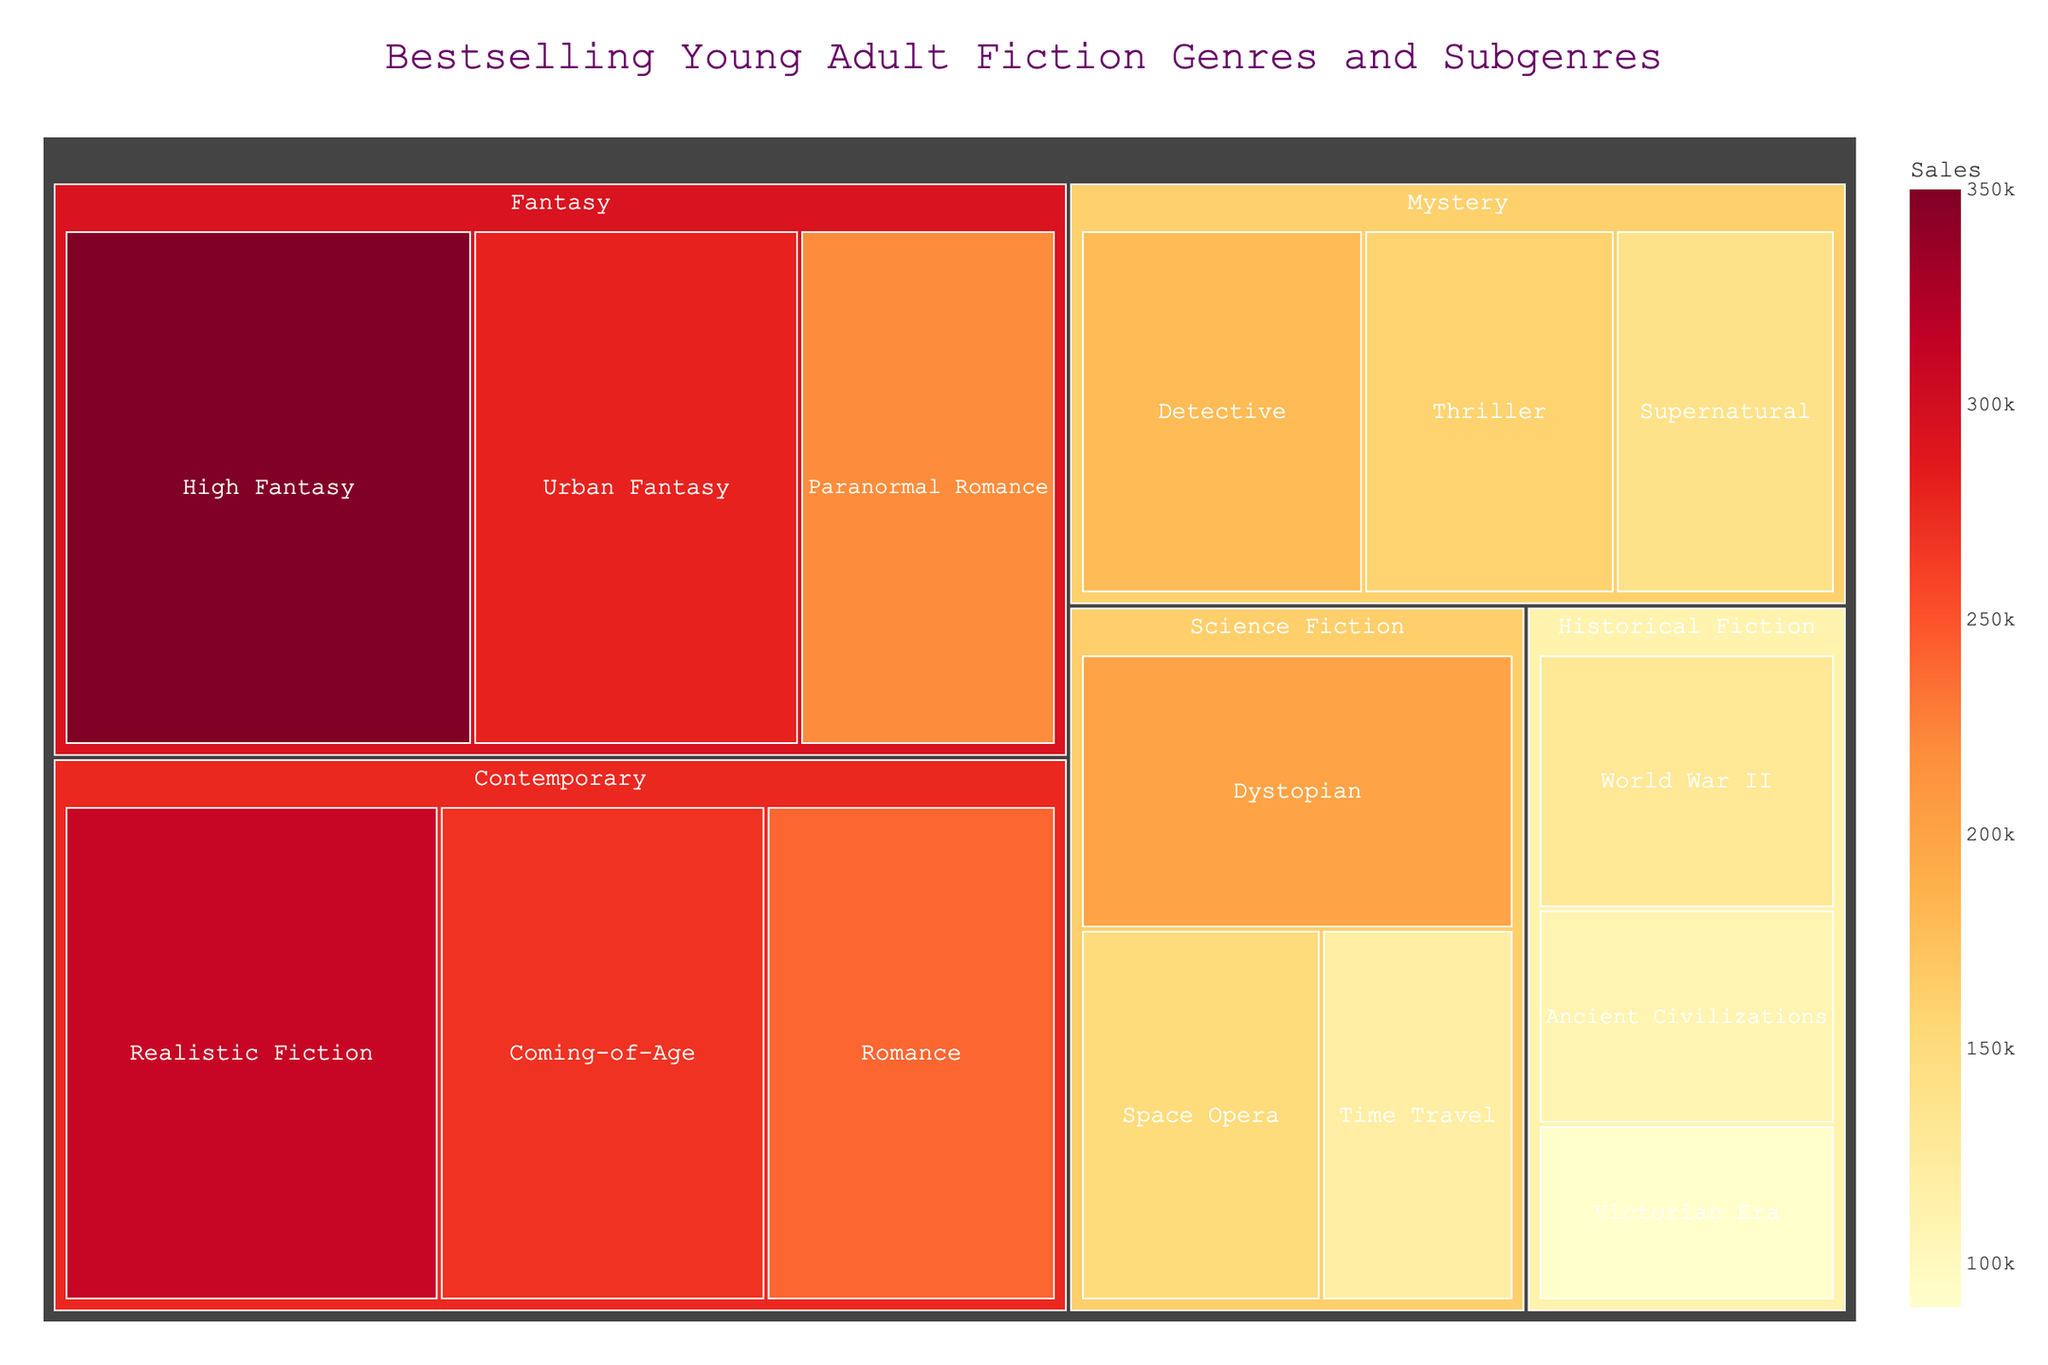What's the title of the figure? The title is usually found at the top of the treemap. It summarizes what the figure is about.
Answer: Bestselling Young Adult Fiction Genres and Subgenres Which subgenre has the highest sales in the Fantasy genre? Look at the Fantasy genre and identify the subgenre within it that has the highest numerical value for sales.
Answer: High Fantasy How much do the total sales for the Mystery genre amount to? Add the sales of all subgenres under the Mystery genre. Detective (180,000) + Thriller (160,000) + Supernatural (140,000) = 480,000
Answer: 480,000 Which subgenre in the Contemporary genre has the lowest sales? Find the subgenre within the Contemporary genre with the smallest sales number.
Answer: Romance Compare the sales of the top subgenre in Fantasy with the top subgenre in Historical Fiction. Which one is higher? Identify the top subgenre in both genres and compare their sales. High Fantasy in Fantasy (350,000) vs World War II in Historical Fiction (130,000).
Answer: High Fantasy What are the sales differences between the highest and lowest subgenre in Science Fiction? Subtract the sales of the lowest subgenre from the highest subgenre within Science Fiction. Space Opera (150,000) - Time Travel (120,000) = 30,000
Answer: 30,000 Which genre has the least total sales? Sum the sales of all subgenres within each genre and find the one with the smallest total. Historical Fiction: 130,000 + 110,000 + 90,000 = 330,000
Answer: Historical Fiction What is the color scale used to represent sales? The color scale indicates sales levels visually. Identify the described color scheme.
Answer: YlOrRd How many subgenres are there in total? Count all the subgenres listed in the figure.
Answer: 15 Which genre appears to have the widest variety of subgenres? Identify the genre featuring the highest number of distinct subcategories.
Answer: Fantasy 